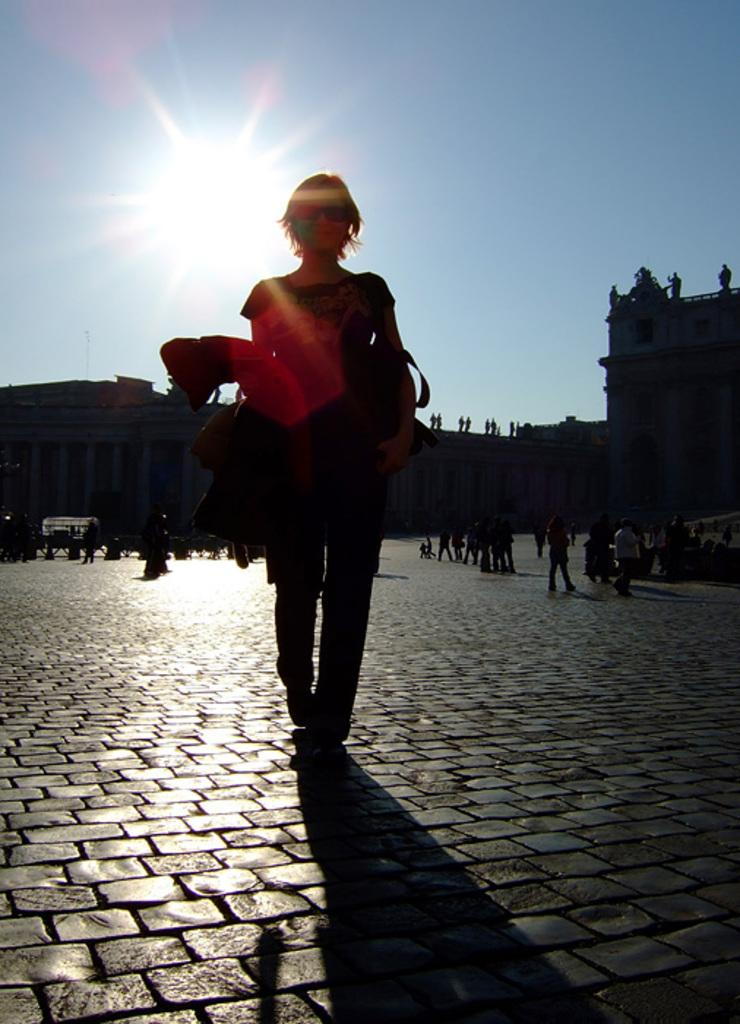What is the main subject of the image? There is a woman standing in the image. What else can be seen in the image besides the woman? There are buildings and groups of people standing in the image. Can you describe the setting of the image? The presence of buildings suggests an urban or city environment. What is the rate at which the fireman is running in the image? There is no fireman present in the image, so it is not possible to determine the rate at which they might be running. 